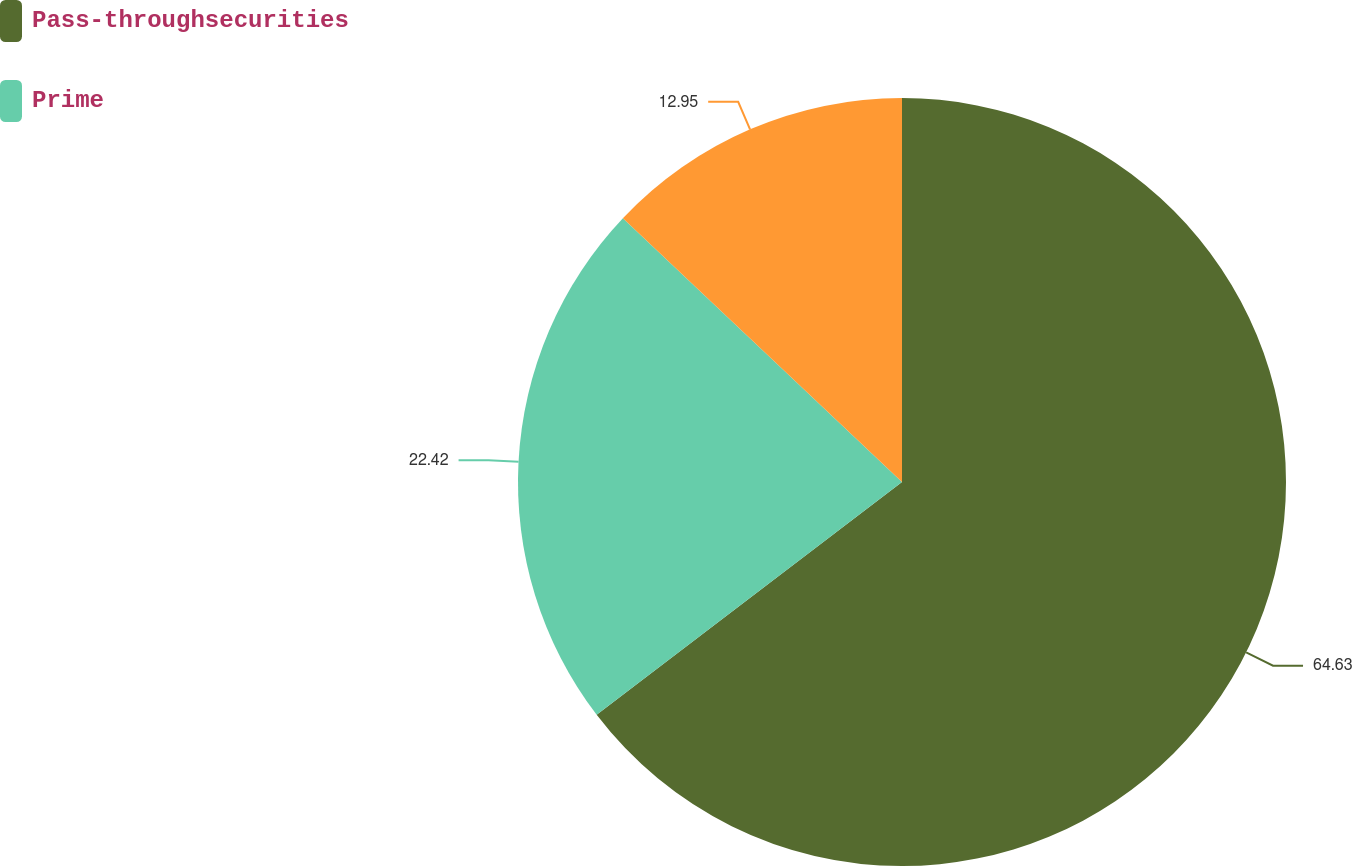<chart> <loc_0><loc_0><loc_500><loc_500><pie_chart><fcel>Pass-throughsecurities<fcel>Prime<fcel>Unnamed: 2<nl><fcel>64.63%<fcel>22.42%<fcel>12.95%<nl></chart> 